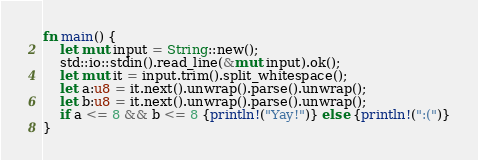Convert code to text. <code><loc_0><loc_0><loc_500><loc_500><_Rust_>fn main() {
    let mut input = String::new();
    std::io::stdin().read_line(&mut input).ok();
    let mut it = input.trim().split_whitespace();
    let a:u8 = it.next().unwrap().parse().unwrap();
    let b:u8 = it.next().unwrap().parse().unwrap();
    if a <= 8 && b <= 8 {println!("Yay!")} else {println!(":(")}
}</code> 